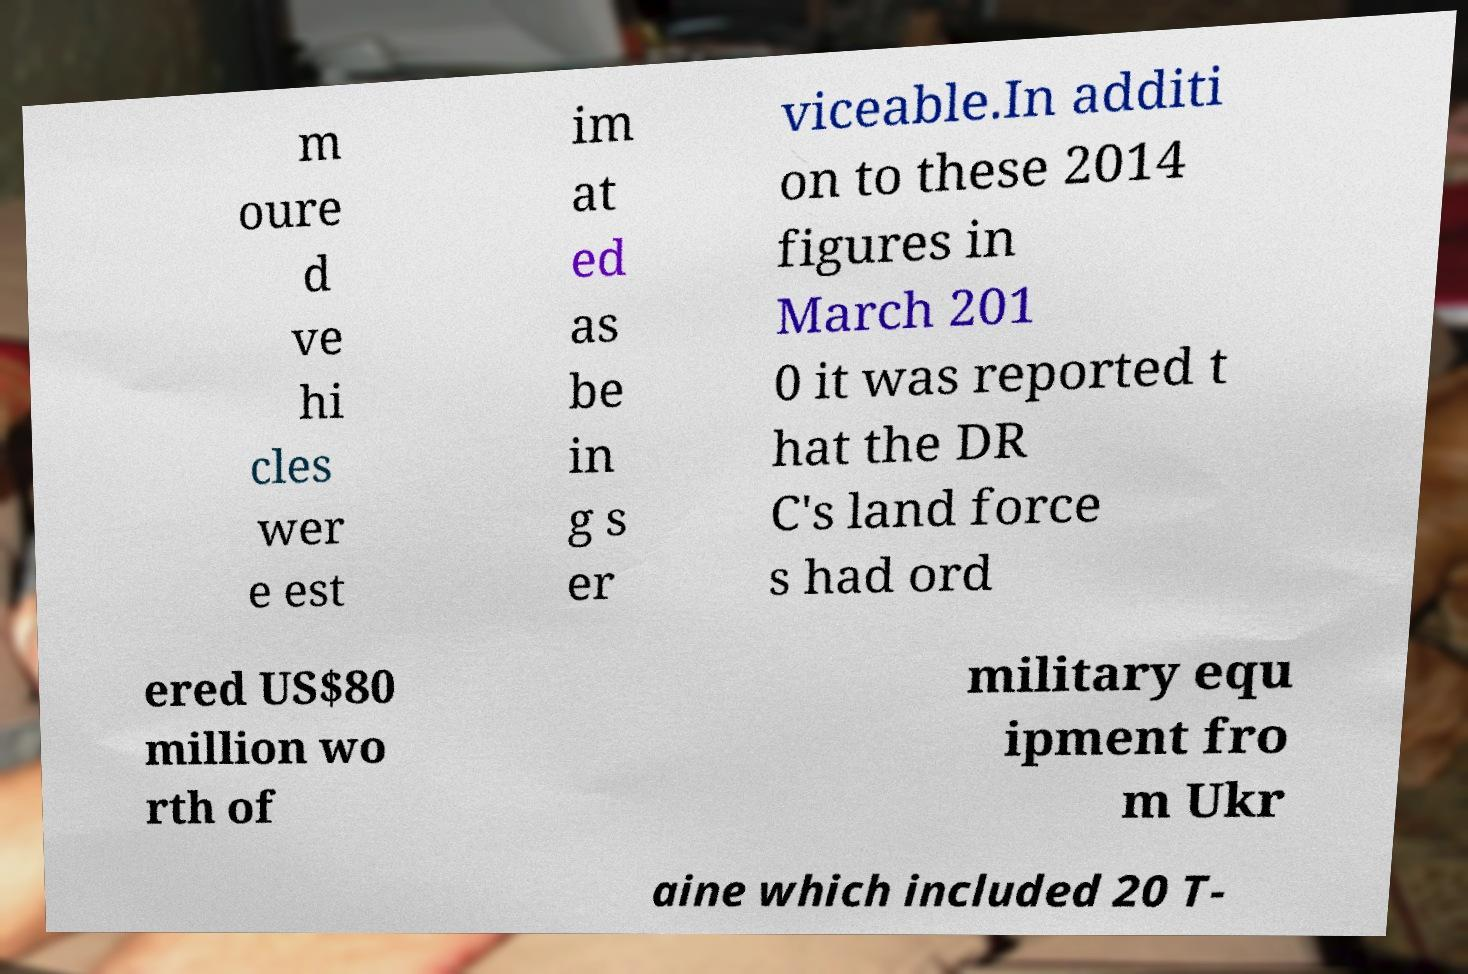Please read and relay the text visible in this image. What does it say? m oure d ve hi cles wer e est im at ed as be in g s er viceable.In additi on to these 2014 figures in March 201 0 it was reported t hat the DR C's land force s had ord ered US$80 million wo rth of military equ ipment fro m Ukr aine which included 20 T- 